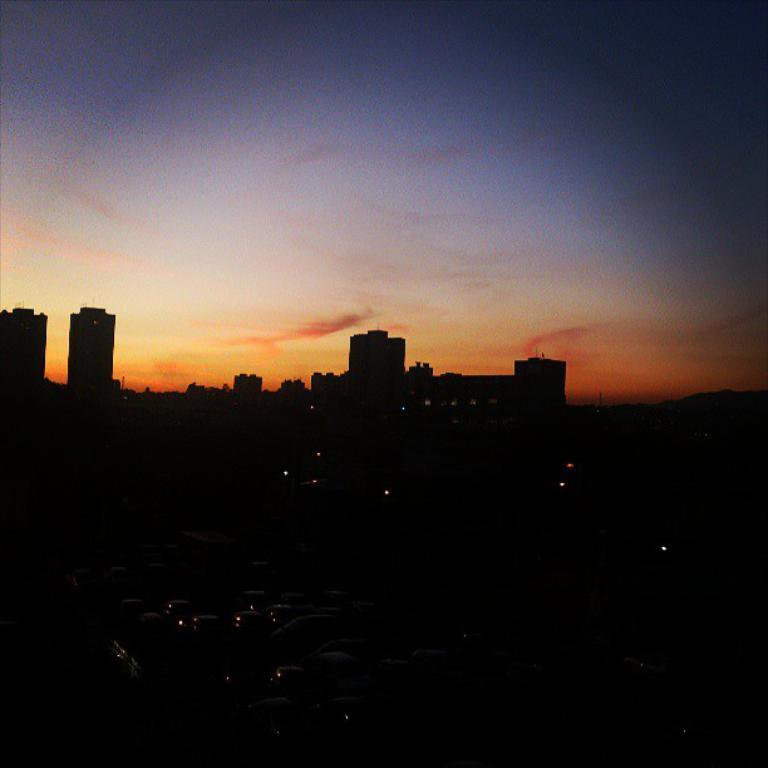What type of artificial light source is visible in the image? There are electric lights in the image. What type of structures can be seen in the image? There are buildings in the image. What is visible in the sky in the image? The sky is visible in the image, and there are clouds in the sky. Can you tell me how many alarm clocks are visible in the image? There are no alarm clocks present in the image. Is there a lake visible in the image? There is no lake present in the image. 